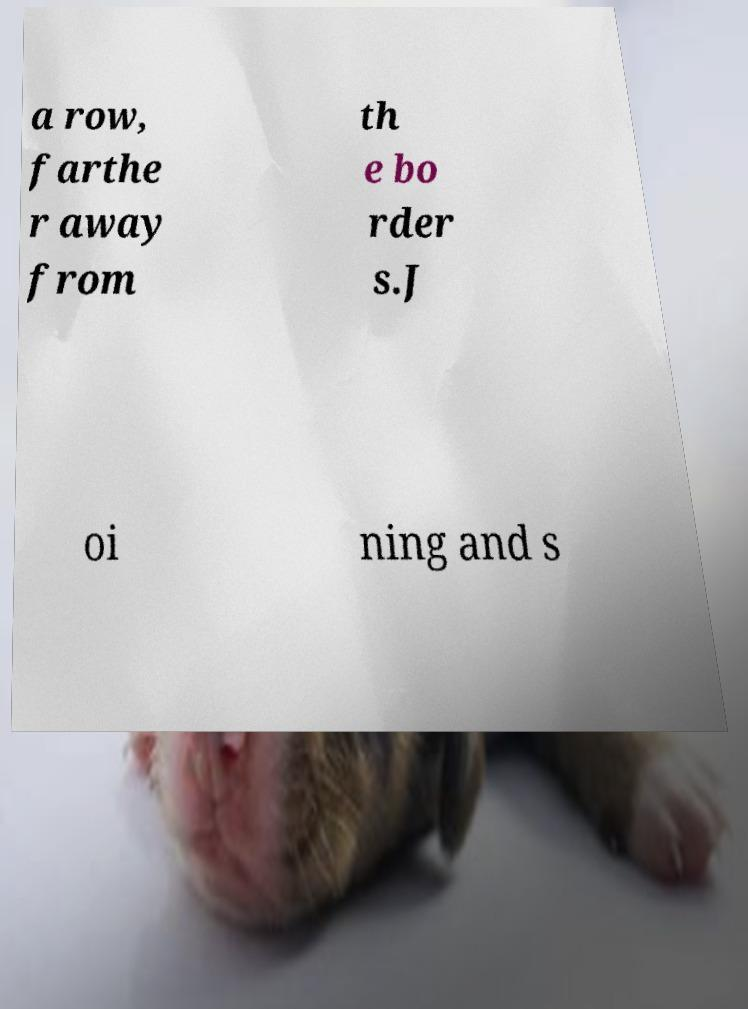Can you read and provide the text displayed in the image?This photo seems to have some interesting text. Can you extract and type it out for me? a row, farthe r away from th e bo rder s.J oi ning and s 